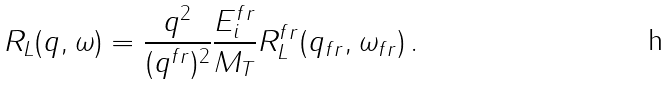Convert formula to latex. <formula><loc_0><loc_0><loc_500><loc_500>R _ { L } ( q , \omega ) = \frac { q ^ { 2 } } { ( q ^ { f r } ) ^ { 2 } } { \frac { E _ { i } ^ { f r } } { M _ { T } } } R _ { L } ^ { f r } ( q _ { f r } , \omega _ { f r } ) \, .</formula> 